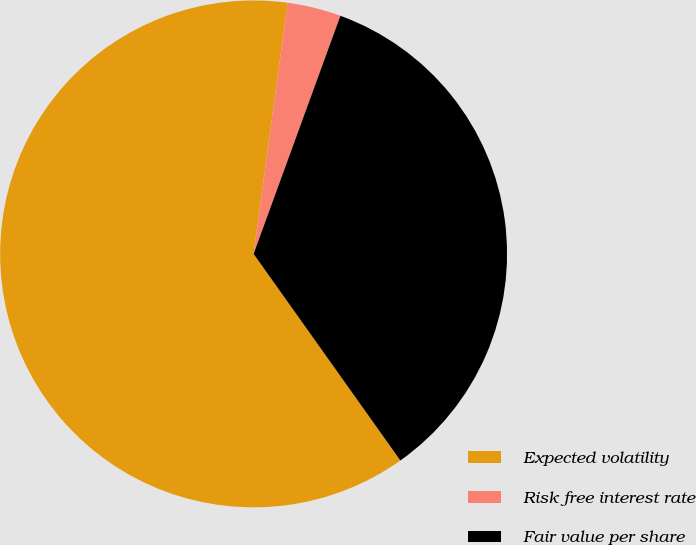Convert chart to OTSL. <chart><loc_0><loc_0><loc_500><loc_500><pie_chart><fcel>Expected volatility<fcel>Risk free interest rate<fcel>Fair value per share<nl><fcel>61.97%<fcel>3.42%<fcel>34.6%<nl></chart> 